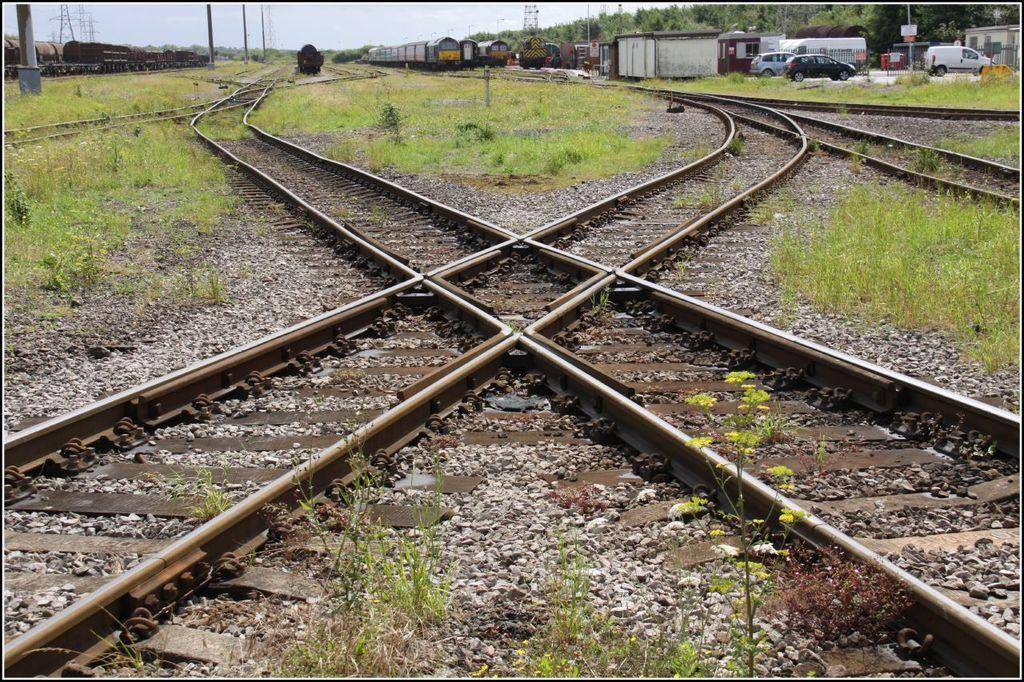What is located in the center of the image? There are tracks in the center of the image. What types of vehicles are present in the image? There are trains and cars in the image. Where are the trains and cars located in the image? The trains and cars are at the top side of the image. What type of vegetation can be seen on both sides of the image? There is grass land on the right side and the left side of the image. How many cattle are grazing on the grass land on the right side of the image? There are no cattle present in the image; it only features tracks, trains, cars, and grass land. What is the limit of the grass land on the left side of the image? The grass land on the left side of the image does not have a limit within the image; it extends to the edge of the frame. 